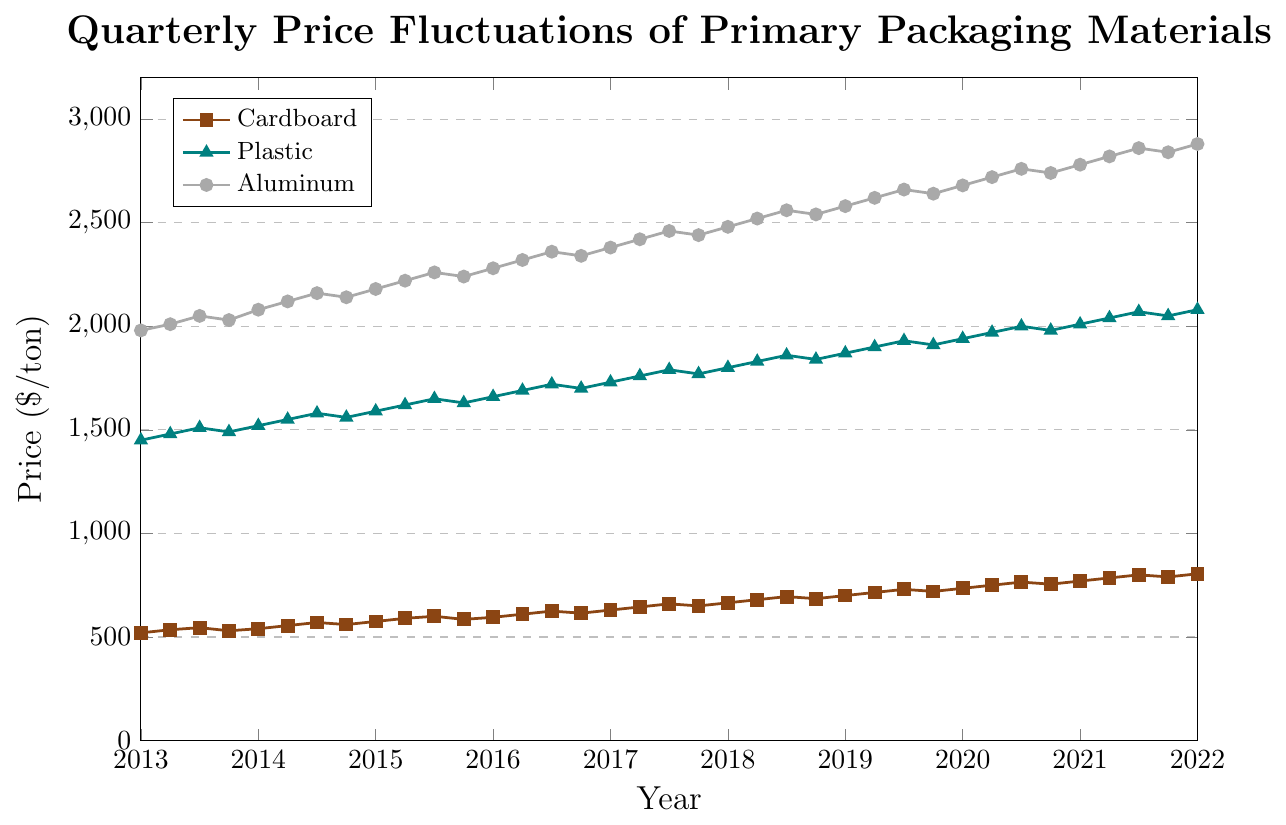What is the trend in the price of cardboard from 2013 to 2022? To identify the trend, we observe the overall movement of the cardboard price line from 2013 to 2022. The line generally ascends, indicating an increase in the price of cardboard over this period.
Answer: Increasing Which material had the highest price in Q1 of 2016? The prices in Q1 2016 are Cardboard ($595/ton), Plastic ($1660/ton), and Aluminum ($2280/ton). Among these, Aluminum has the highest price.
Answer: Aluminum What is the average price of plastic in 2017? The quarterly prices of plastic in 2017 are $1730, $1760, $1790, and $1770. Summing these gives $1730 + $1760 + $1790 + $1770 = $7050. The average is $7050 / 4 = $1762.5.
Answer: $1762.5 What color represents the price of aluminum on the plot? The color representing aluminum is consistently grey.
Answer: Grey Between 2018 and 2019, which material experienced the highest increase in price? By analyzing the yearly average price for each material, we see: Cardboard: ($665 + $680 + $695 + $685)/4 = $681.25 in 2018, ($700 + $715 + $730 + $720)/4 = $716.25 in 2019; increase = $716.25 - $681.25 = $35. Plastic: ($1800 + $1830 + $1860 + $1840)/4 = $1832.5 in 2018, ($1870 + $1900 + $1930 + $1910)/4 = $1902.5 in 2019; increase = $1902.5 - $1832.5 = $70. Aluminum: ($2480 + $2520 + $2560 + $2540)/4 = $2525 in 2018, ($2580 + $2620 + $2660 + $2640)/4 = $2625 in 2019; increase = $100. Aluminum had the highest increase.
Answer: Aluminum During which quarter in 2020 did the price of plastic peak, and what was the price? Observing the line chart for 2020, the peak price for plastic is in Q3, valued at $2000 per ton.
Answer: Q3, $2000 Calculate the rate of price increase for aluminum from Q1 2021 to Q3 2021. The price in Q1 2021 was $2780/ton, and in Q3 2021, it was $2860/ton. The rate of increase is ($2860 - $2780) / $2780 = 80 / 2780 ≈ 0.0288, or approximately 2.88%.
Answer: 2.88% Compare the price changes of cardboard and plastic between Q2 2015 and Q2 2016. Which material saw a higher absolute increase? Cardboard in Q2 2015 is $590/ton and in Q2 2016 is $610/ton, increase = $610 - $590 = $20. Plastic in Q2 2015 is $1620/ton and in Q2 2016 is $1690/ton, increase = $1690 - $1620 = $70. Plastic saw a higher increase.
Answer: Plastic What is the lowest price recorded for aluminum across the entire timeline? Examining the aluminum prices, the lowest price observed is $1980/ton in Q1 2013.
Answer: $1980/ton 